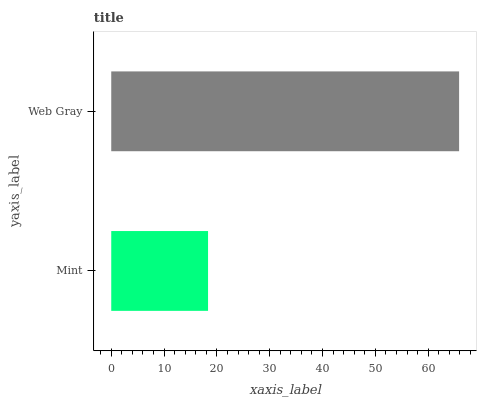Is Mint the minimum?
Answer yes or no. Yes. Is Web Gray the maximum?
Answer yes or no. Yes. Is Web Gray the minimum?
Answer yes or no. No. Is Web Gray greater than Mint?
Answer yes or no. Yes. Is Mint less than Web Gray?
Answer yes or no. Yes. Is Mint greater than Web Gray?
Answer yes or no. No. Is Web Gray less than Mint?
Answer yes or no. No. Is Web Gray the high median?
Answer yes or no. Yes. Is Mint the low median?
Answer yes or no. Yes. Is Mint the high median?
Answer yes or no. No. Is Web Gray the low median?
Answer yes or no. No. 